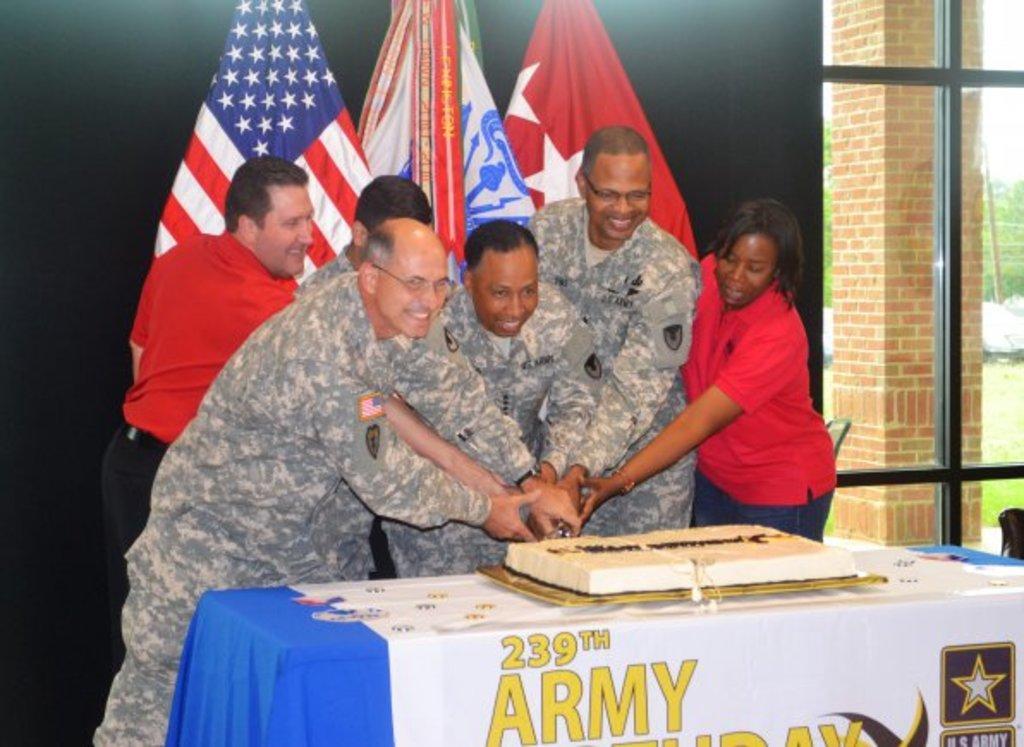In one or two sentences, can you explain what this image depicts? In the picture I can see five men and a woman. They are cutting a cake and there is a smile on their face. I can see the table which is covered with design cloth. I can see the glass window and the brick pillar on the right side. In the background, I can see the flag poles. I can see the trees and vehicles on the right side. 